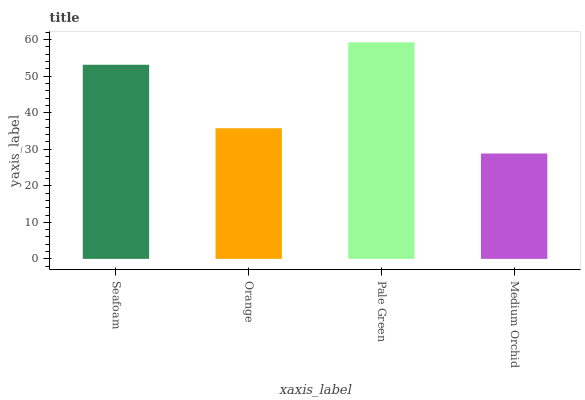Is Medium Orchid the minimum?
Answer yes or no. Yes. Is Pale Green the maximum?
Answer yes or no. Yes. Is Orange the minimum?
Answer yes or no. No. Is Orange the maximum?
Answer yes or no. No. Is Seafoam greater than Orange?
Answer yes or no. Yes. Is Orange less than Seafoam?
Answer yes or no. Yes. Is Orange greater than Seafoam?
Answer yes or no. No. Is Seafoam less than Orange?
Answer yes or no. No. Is Seafoam the high median?
Answer yes or no. Yes. Is Orange the low median?
Answer yes or no. Yes. Is Medium Orchid the high median?
Answer yes or no. No. Is Seafoam the low median?
Answer yes or no. No. 